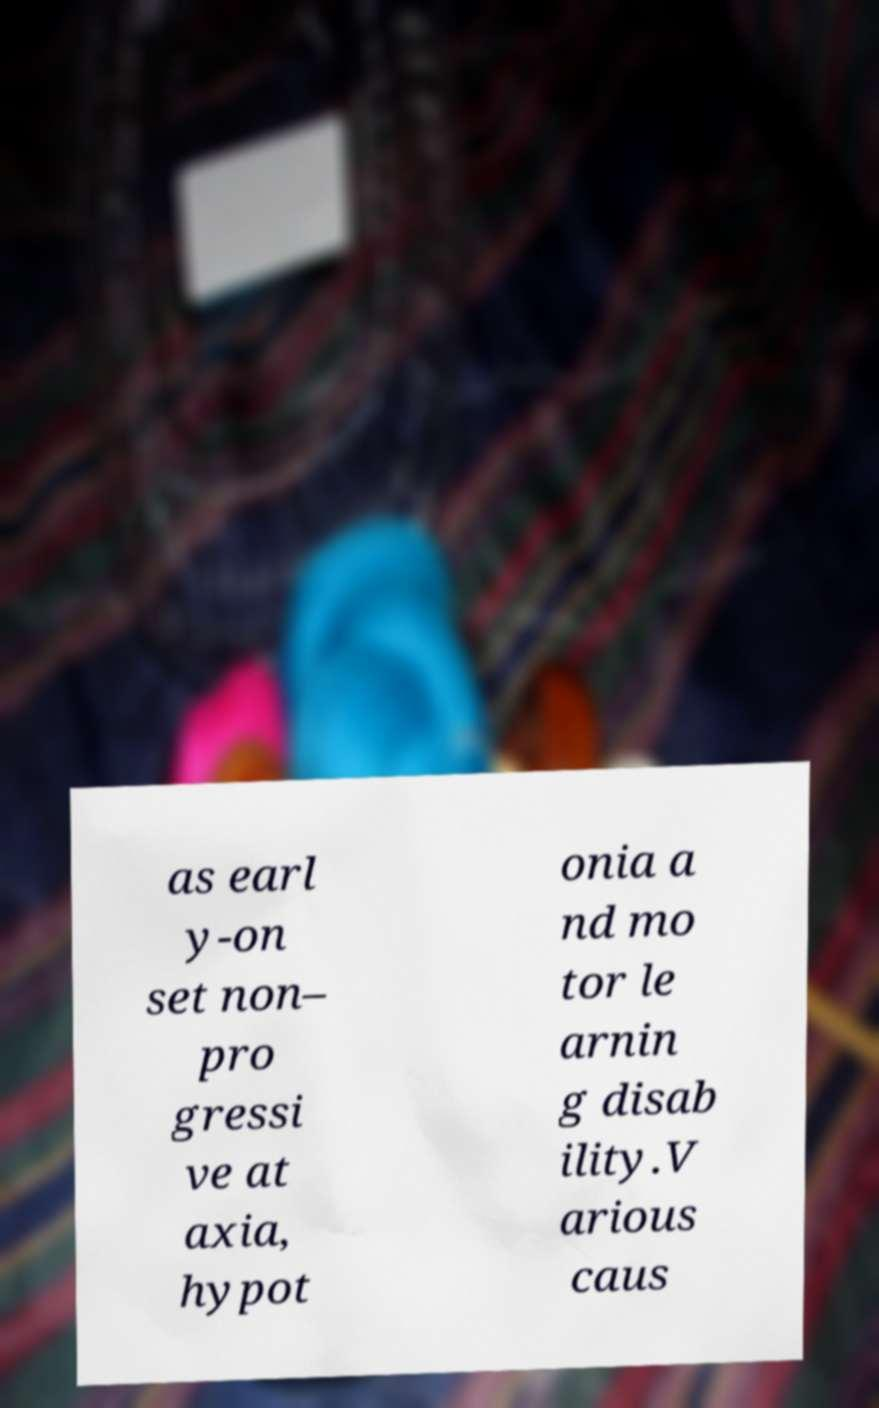Can you read and provide the text displayed in the image?This photo seems to have some interesting text. Can you extract and type it out for me? as earl y-on set non– pro gressi ve at axia, hypot onia a nd mo tor le arnin g disab ility.V arious caus 